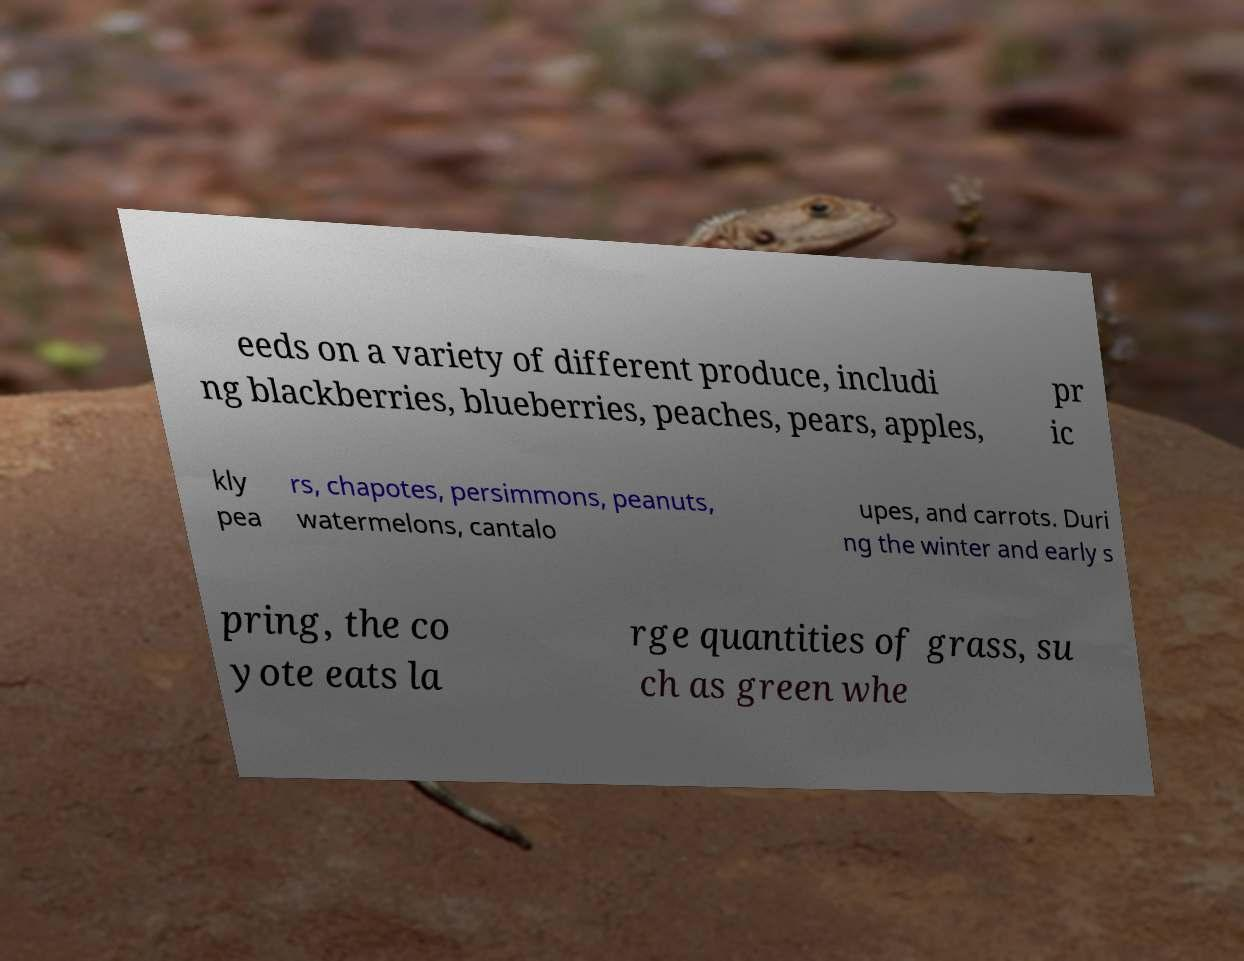For documentation purposes, I need the text within this image transcribed. Could you provide that? eeds on a variety of different produce, includi ng blackberries, blueberries, peaches, pears, apples, pr ic kly pea rs, chapotes, persimmons, peanuts, watermelons, cantalo upes, and carrots. Duri ng the winter and early s pring, the co yote eats la rge quantities of grass, su ch as green whe 